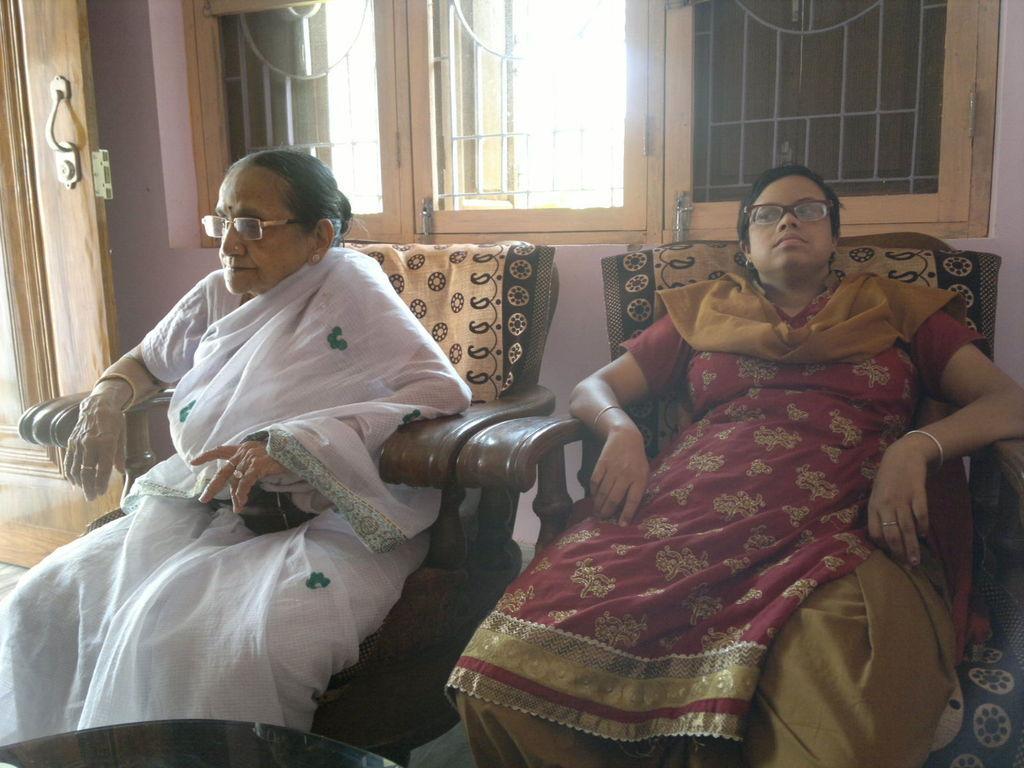In one or two sentences, can you explain what this image depicts? This picture is clicked inside the room. In the center we can see the two women sitting on the sofas. In the foreground we can see a table. In the background can see the wall, wooden door and the windows. 